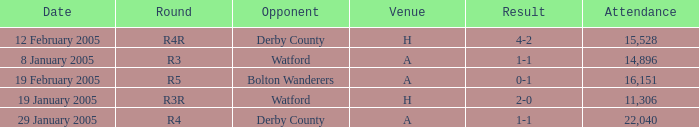Can you parse all the data within this table? {'header': ['Date', 'Round', 'Opponent', 'Venue', 'Result', 'Attendance'], 'rows': [['12 February 2005', 'R4R', 'Derby County', 'H', '4-2', '15,528'], ['8 January 2005', 'R3', 'Watford', 'A', '1-1', '14,896'], ['19 February 2005', 'R5', 'Bolton Wanderers', 'A', '0-1', '16,151'], ['19 January 2005', 'R3R', 'Watford', 'H', '2-0', '11,306'], ['29 January 2005', 'R4', 'Derby County', 'A', '1-1', '22,040']]} What is the round of the game at venue H and opponent of Derby County? R4R. 